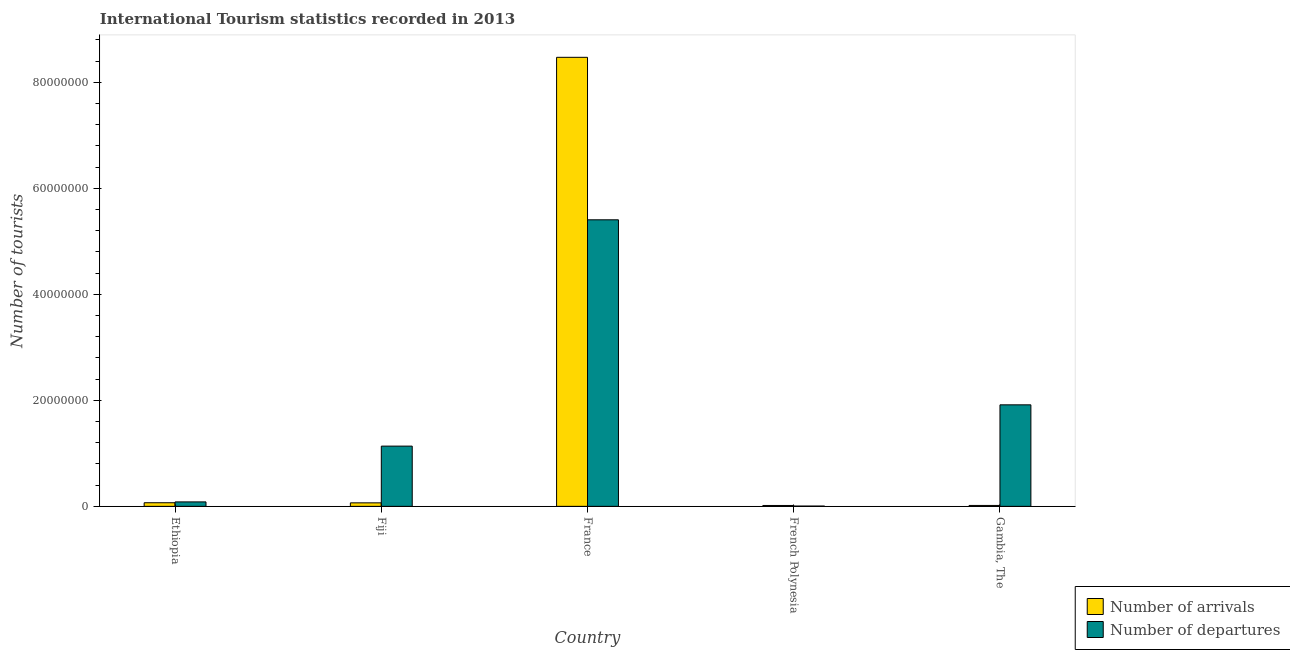How many groups of bars are there?
Your answer should be very brief. 5. Are the number of bars per tick equal to the number of legend labels?
Provide a succinct answer. Yes. How many bars are there on the 2nd tick from the right?
Offer a terse response. 2. What is the label of the 3rd group of bars from the left?
Make the answer very short. France. What is the number of tourist arrivals in French Polynesia?
Offer a very short reply. 1.64e+05. Across all countries, what is the maximum number of tourist arrivals?
Make the answer very short. 8.47e+07. Across all countries, what is the minimum number of tourist arrivals?
Give a very brief answer. 1.64e+05. In which country was the number of tourist departures maximum?
Keep it short and to the point. France. In which country was the number of tourist departures minimum?
Give a very brief answer. French Polynesia. What is the total number of tourist departures in the graph?
Provide a short and direct response. 8.55e+07. What is the difference between the number of tourist arrivals in Ethiopia and that in Fiji?
Provide a succinct answer. 2.30e+04. What is the difference between the number of tourist arrivals in Fiji and the number of tourist departures in France?
Ensure brevity in your answer.  -5.34e+07. What is the average number of tourist arrivals per country?
Your answer should be very brief. 1.73e+07. What is the difference between the number of tourist departures and number of tourist arrivals in Fiji?
Offer a very short reply. 1.07e+07. In how many countries, is the number of tourist arrivals greater than 64000000 ?
Your answer should be compact. 1. What is the ratio of the number of tourist departures in French Polynesia to that in Gambia, The?
Your answer should be very brief. 0. What is the difference between the highest and the second highest number of tourist departures?
Provide a short and direct response. 3.49e+07. What is the difference between the highest and the lowest number of tourist arrivals?
Your answer should be very brief. 8.46e+07. In how many countries, is the number of tourist departures greater than the average number of tourist departures taken over all countries?
Give a very brief answer. 2. Is the sum of the number of tourist departures in Ethiopia and France greater than the maximum number of tourist arrivals across all countries?
Give a very brief answer. No. What does the 2nd bar from the left in France represents?
Make the answer very short. Number of departures. What does the 2nd bar from the right in Gambia, The represents?
Give a very brief answer. Number of arrivals. How many bars are there?
Your answer should be compact. 10. Are all the bars in the graph horizontal?
Your response must be concise. No. How many legend labels are there?
Your response must be concise. 2. What is the title of the graph?
Your answer should be compact. International Tourism statistics recorded in 2013. What is the label or title of the Y-axis?
Your response must be concise. Number of tourists. What is the Number of tourists of Number of arrivals in Ethiopia?
Make the answer very short. 6.81e+05. What is the Number of tourists in Number of departures in Ethiopia?
Offer a very short reply. 8.39e+05. What is the Number of tourists of Number of arrivals in Fiji?
Offer a very short reply. 6.58e+05. What is the Number of tourists of Number of departures in Fiji?
Your answer should be very brief. 1.14e+07. What is the Number of tourists in Number of arrivals in France?
Make the answer very short. 8.47e+07. What is the Number of tourists in Number of departures in France?
Your response must be concise. 5.41e+07. What is the Number of tourists in Number of arrivals in French Polynesia?
Give a very brief answer. 1.64e+05. What is the Number of tourists in Number of departures in French Polynesia?
Offer a terse response. 5.10e+04. What is the Number of tourists in Number of arrivals in Gambia, The?
Your response must be concise. 1.71e+05. What is the Number of tourists of Number of departures in Gambia, The?
Your response must be concise. 1.92e+07. Across all countries, what is the maximum Number of tourists in Number of arrivals?
Your answer should be compact. 8.47e+07. Across all countries, what is the maximum Number of tourists of Number of departures?
Keep it short and to the point. 5.41e+07. Across all countries, what is the minimum Number of tourists in Number of arrivals?
Offer a very short reply. 1.64e+05. Across all countries, what is the minimum Number of tourists in Number of departures?
Offer a terse response. 5.10e+04. What is the total Number of tourists of Number of arrivals in the graph?
Ensure brevity in your answer.  8.64e+07. What is the total Number of tourists of Number of departures in the graph?
Provide a short and direct response. 8.55e+07. What is the difference between the Number of tourists of Number of arrivals in Ethiopia and that in Fiji?
Your answer should be compact. 2.30e+04. What is the difference between the Number of tourists in Number of departures in Ethiopia and that in Fiji?
Offer a terse response. -1.05e+07. What is the difference between the Number of tourists in Number of arrivals in Ethiopia and that in France?
Keep it short and to the point. -8.40e+07. What is the difference between the Number of tourists of Number of departures in Ethiopia and that in France?
Offer a very short reply. -5.32e+07. What is the difference between the Number of tourists of Number of arrivals in Ethiopia and that in French Polynesia?
Give a very brief answer. 5.17e+05. What is the difference between the Number of tourists of Number of departures in Ethiopia and that in French Polynesia?
Provide a short and direct response. 7.88e+05. What is the difference between the Number of tourists in Number of arrivals in Ethiopia and that in Gambia, The?
Your answer should be very brief. 5.10e+05. What is the difference between the Number of tourists in Number of departures in Ethiopia and that in Gambia, The?
Your answer should be very brief. -1.83e+07. What is the difference between the Number of tourists of Number of arrivals in Fiji and that in France?
Ensure brevity in your answer.  -8.41e+07. What is the difference between the Number of tourists of Number of departures in Fiji and that in France?
Provide a short and direct response. -4.27e+07. What is the difference between the Number of tourists of Number of arrivals in Fiji and that in French Polynesia?
Make the answer very short. 4.94e+05. What is the difference between the Number of tourists of Number of departures in Fiji and that in French Polynesia?
Keep it short and to the point. 1.13e+07. What is the difference between the Number of tourists in Number of arrivals in Fiji and that in Gambia, The?
Give a very brief answer. 4.87e+05. What is the difference between the Number of tourists of Number of departures in Fiji and that in Gambia, The?
Provide a short and direct response. -7.79e+06. What is the difference between the Number of tourists in Number of arrivals in France and that in French Polynesia?
Your answer should be compact. 8.46e+07. What is the difference between the Number of tourists of Number of departures in France and that in French Polynesia?
Your answer should be very brief. 5.40e+07. What is the difference between the Number of tourists of Number of arrivals in France and that in Gambia, The?
Make the answer very short. 8.46e+07. What is the difference between the Number of tourists in Number of departures in France and that in Gambia, The?
Ensure brevity in your answer.  3.49e+07. What is the difference between the Number of tourists of Number of arrivals in French Polynesia and that in Gambia, The?
Your answer should be compact. -7000. What is the difference between the Number of tourists of Number of departures in French Polynesia and that in Gambia, The?
Provide a short and direct response. -1.91e+07. What is the difference between the Number of tourists of Number of arrivals in Ethiopia and the Number of tourists of Number of departures in Fiji?
Your answer should be very brief. -1.07e+07. What is the difference between the Number of tourists in Number of arrivals in Ethiopia and the Number of tourists in Number of departures in France?
Offer a terse response. -5.34e+07. What is the difference between the Number of tourists in Number of arrivals in Ethiopia and the Number of tourists in Number of departures in French Polynesia?
Offer a very short reply. 6.30e+05. What is the difference between the Number of tourists of Number of arrivals in Ethiopia and the Number of tourists of Number of departures in Gambia, The?
Your answer should be compact. -1.85e+07. What is the difference between the Number of tourists of Number of arrivals in Fiji and the Number of tourists of Number of departures in France?
Your answer should be very brief. -5.34e+07. What is the difference between the Number of tourists of Number of arrivals in Fiji and the Number of tourists of Number of departures in French Polynesia?
Offer a terse response. 6.07e+05. What is the difference between the Number of tourists of Number of arrivals in Fiji and the Number of tourists of Number of departures in Gambia, The?
Provide a short and direct response. -1.85e+07. What is the difference between the Number of tourists of Number of arrivals in France and the Number of tourists of Number of departures in French Polynesia?
Your answer should be very brief. 8.47e+07. What is the difference between the Number of tourists in Number of arrivals in France and the Number of tourists in Number of departures in Gambia, The?
Offer a very short reply. 6.56e+07. What is the difference between the Number of tourists in Number of arrivals in French Polynesia and the Number of tourists in Number of departures in Gambia, The?
Your answer should be compact. -1.90e+07. What is the average Number of tourists of Number of arrivals per country?
Offer a terse response. 1.73e+07. What is the average Number of tourists of Number of departures per country?
Offer a terse response. 1.71e+07. What is the difference between the Number of tourists in Number of arrivals and Number of tourists in Number of departures in Ethiopia?
Ensure brevity in your answer.  -1.58e+05. What is the difference between the Number of tourists of Number of arrivals and Number of tourists of Number of departures in Fiji?
Your response must be concise. -1.07e+07. What is the difference between the Number of tourists of Number of arrivals and Number of tourists of Number of departures in France?
Keep it short and to the point. 3.07e+07. What is the difference between the Number of tourists of Number of arrivals and Number of tourists of Number of departures in French Polynesia?
Keep it short and to the point. 1.13e+05. What is the difference between the Number of tourists in Number of arrivals and Number of tourists in Number of departures in Gambia, The?
Offer a very short reply. -1.90e+07. What is the ratio of the Number of tourists in Number of arrivals in Ethiopia to that in Fiji?
Make the answer very short. 1.03. What is the ratio of the Number of tourists in Number of departures in Ethiopia to that in Fiji?
Your response must be concise. 0.07. What is the ratio of the Number of tourists in Number of arrivals in Ethiopia to that in France?
Provide a short and direct response. 0.01. What is the ratio of the Number of tourists in Number of departures in Ethiopia to that in France?
Give a very brief answer. 0.02. What is the ratio of the Number of tourists of Number of arrivals in Ethiopia to that in French Polynesia?
Provide a short and direct response. 4.15. What is the ratio of the Number of tourists in Number of departures in Ethiopia to that in French Polynesia?
Make the answer very short. 16.45. What is the ratio of the Number of tourists of Number of arrivals in Ethiopia to that in Gambia, The?
Your response must be concise. 3.98. What is the ratio of the Number of tourists in Number of departures in Ethiopia to that in Gambia, The?
Provide a succinct answer. 0.04. What is the ratio of the Number of tourists in Number of arrivals in Fiji to that in France?
Provide a short and direct response. 0.01. What is the ratio of the Number of tourists in Number of departures in Fiji to that in France?
Provide a short and direct response. 0.21. What is the ratio of the Number of tourists in Number of arrivals in Fiji to that in French Polynesia?
Your answer should be compact. 4.01. What is the ratio of the Number of tourists of Number of departures in Fiji to that in French Polynesia?
Keep it short and to the point. 222.82. What is the ratio of the Number of tourists in Number of arrivals in Fiji to that in Gambia, The?
Keep it short and to the point. 3.85. What is the ratio of the Number of tourists in Number of departures in Fiji to that in Gambia, The?
Provide a succinct answer. 0.59. What is the ratio of the Number of tourists in Number of arrivals in France to that in French Polynesia?
Provide a short and direct response. 516.62. What is the ratio of the Number of tourists of Number of departures in France to that in French Polynesia?
Make the answer very short. 1060.18. What is the ratio of the Number of tourists in Number of arrivals in France to that in Gambia, The?
Offer a very short reply. 495.47. What is the ratio of the Number of tourists in Number of departures in France to that in Gambia, The?
Make the answer very short. 2.82. What is the ratio of the Number of tourists of Number of arrivals in French Polynesia to that in Gambia, The?
Your response must be concise. 0.96. What is the ratio of the Number of tourists in Number of departures in French Polynesia to that in Gambia, The?
Ensure brevity in your answer.  0. What is the difference between the highest and the second highest Number of tourists of Number of arrivals?
Provide a short and direct response. 8.40e+07. What is the difference between the highest and the second highest Number of tourists in Number of departures?
Ensure brevity in your answer.  3.49e+07. What is the difference between the highest and the lowest Number of tourists in Number of arrivals?
Your response must be concise. 8.46e+07. What is the difference between the highest and the lowest Number of tourists of Number of departures?
Offer a very short reply. 5.40e+07. 